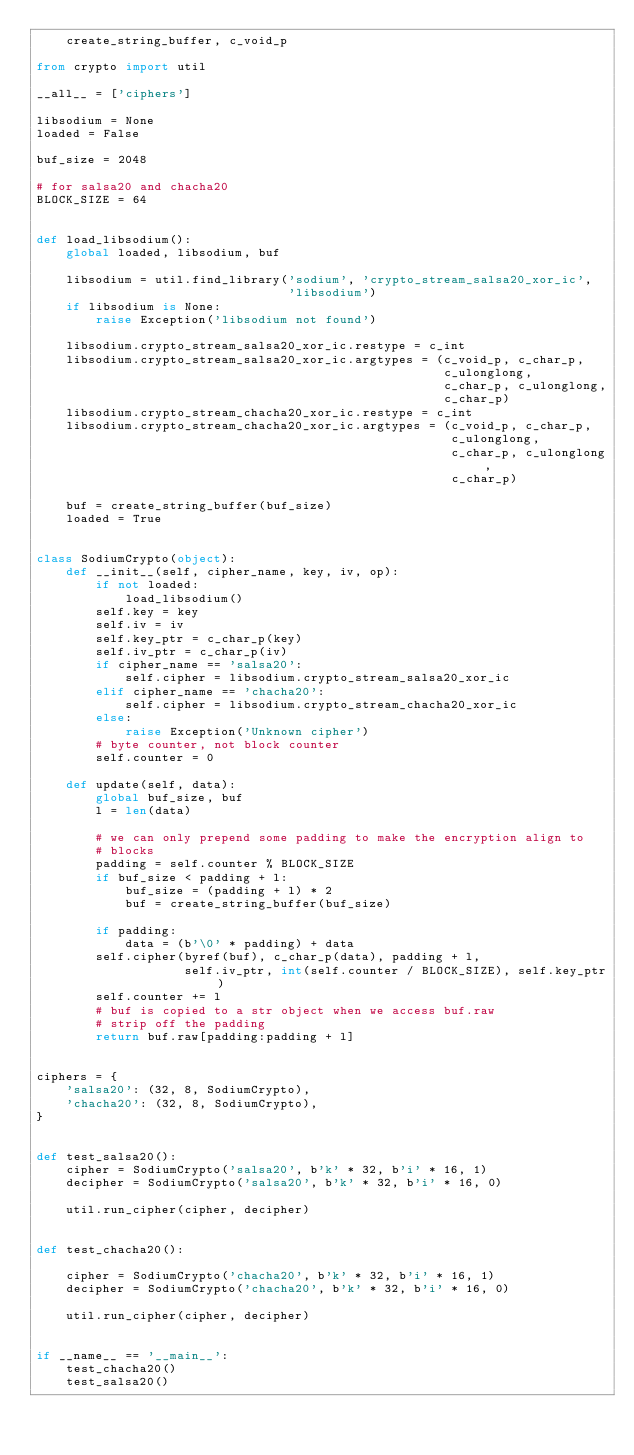<code> <loc_0><loc_0><loc_500><loc_500><_Python_>    create_string_buffer, c_void_p

from crypto import util

__all__ = ['ciphers']

libsodium = None
loaded = False

buf_size = 2048

# for salsa20 and chacha20
BLOCK_SIZE = 64


def load_libsodium():
    global loaded, libsodium, buf

    libsodium = util.find_library('sodium', 'crypto_stream_salsa20_xor_ic',
                                  'libsodium')
    if libsodium is None:
        raise Exception('libsodium not found')

    libsodium.crypto_stream_salsa20_xor_ic.restype = c_int
    libsodium.crypto_stream_salsa20_xor_ic.argtypes = (c_void_p, c_char_p,
                                                       c_ulonglong,
                                                       c_char_p, c_ulonglong,
                                                       c_char_p)
    libsodium.crypto_stream_chacha20_xor_ic.restype = c_int
    libsodium.crypto_stream_chacha20_xor_ic.argtypes = (c_void_p, c_char_p,
                                                        c_ulonglong,
                                                        c_char_p, c_ulonglong,
                                                        c_char_p)

    buf = create_string_buffer(buf_size)
    loaded = True


class SodiumCrypto(object):
    def __init__(self, cipher_name, key, iv, op):
        if not loaded:
            load_libsodium()
        self.key = key
        self.iv = iv
        self.key_ptr = c_char_p(key)
        self.iv_ptr = c_char_p(iv)
        if cipher_name == 'salsa20':
            self.cipher = libsodium.crypto_stream_salsa20_xor_ic
        elif cipher_name == 'chacha20':
            self.cipher = libsodium.crypto_stream_chacha20_xor_ic
        else:
            raise Exception('Unknown cipher')
        # byte counter, not block counter
        self.counter = 0

    def update(self, data):
        global buf_size, buf
        l = len(data)

        # we can only prepend some padding to make the encryption align to
        # blocks
        padding = self.counter % BLOCK_SIZE
        if buf_size < padding + l:
            buf_size = (padding + l) * 2
            buf = create_string_buffer(buf_size)

        if padding:
            data = (b'\0' * padding) + data
        self.cipher(byref(buf), c_char_p(data), padding + l,
                    self.iv_ptr, int(self.counter / BLOCK_SIZE), self.key_ptr)
        self.counter += l
        # buf is copied to a str object when we access buf.raw
        # strip off the padding
        return buf.raw[padding:padding + l]


ciphers = {
    'salsa20': (32, 8, SodiumCrypto),
    'chacha20': (32, 8, SodiumCrypto),
}


def test_salsa20():
    cipher = SodiumCrypto('salsa20', b'k' * 32, b'i' * 16, 1)
    decipher = SodiumCrypto('salsa20', b'k' * 32, b'i' * 16, 0)

    util.run_cipher(cipher, decipher)


def test_chacha20():

    cipher = SodiumCrypto('chacha20', b'k' * 32, b'i' * 16, 1)
    decipher = SodiumCrypto('chacha20', b'k' * 32, b'i' * 16, 0)

    util.run_cipher(cipher, decipher)


if __name__ == '__main__':
    test_chacha20()
    test_salsa20()
</code> 